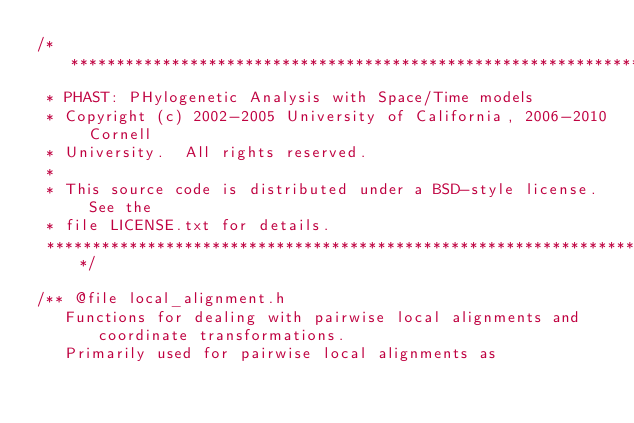<code> <loc_0><loc_0><loc_500><loc_500><_C_>/***************************************************************************
 * PHAST: PHylogenetic Analysis with Space/Time models
 * Copyright (c) 2002-2005 University of California, 2006-2010 Cornell 
 * University.  All rights reserved.
 *
 * This source code is distributed under a BSD-style license.  See the
 * file LICENSE.txt for details.
 ***************************************************************************/

/** @file local_alignment.h
   Functions for dealing with pairwise local alignments and coordinate transformations.
   Primarily used for pairwise local alignments as</code> 